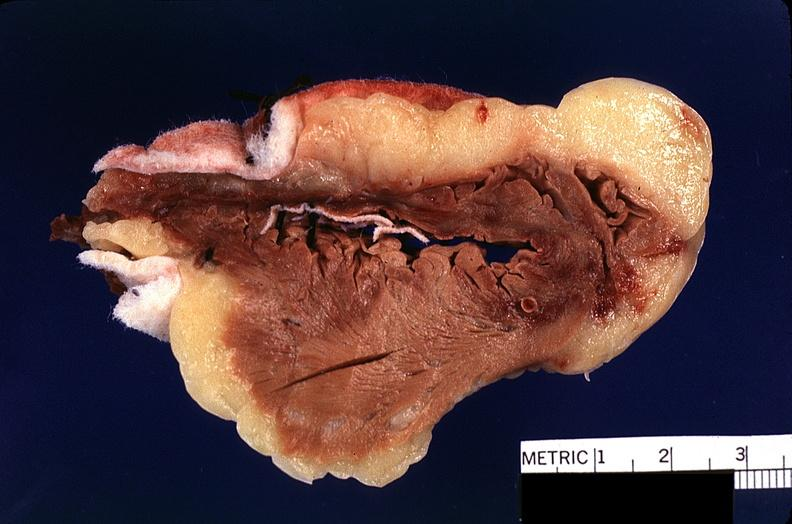what is present?
Answer the question using a single word or phrase. Cardiovascular 